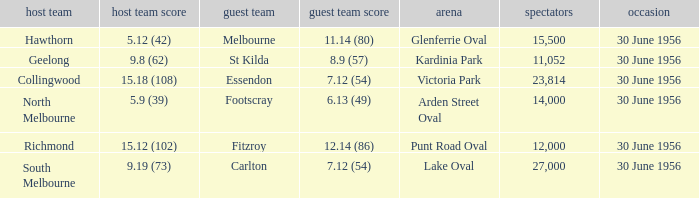What away team has a home team score of 15.18 (108)? Essendon. 